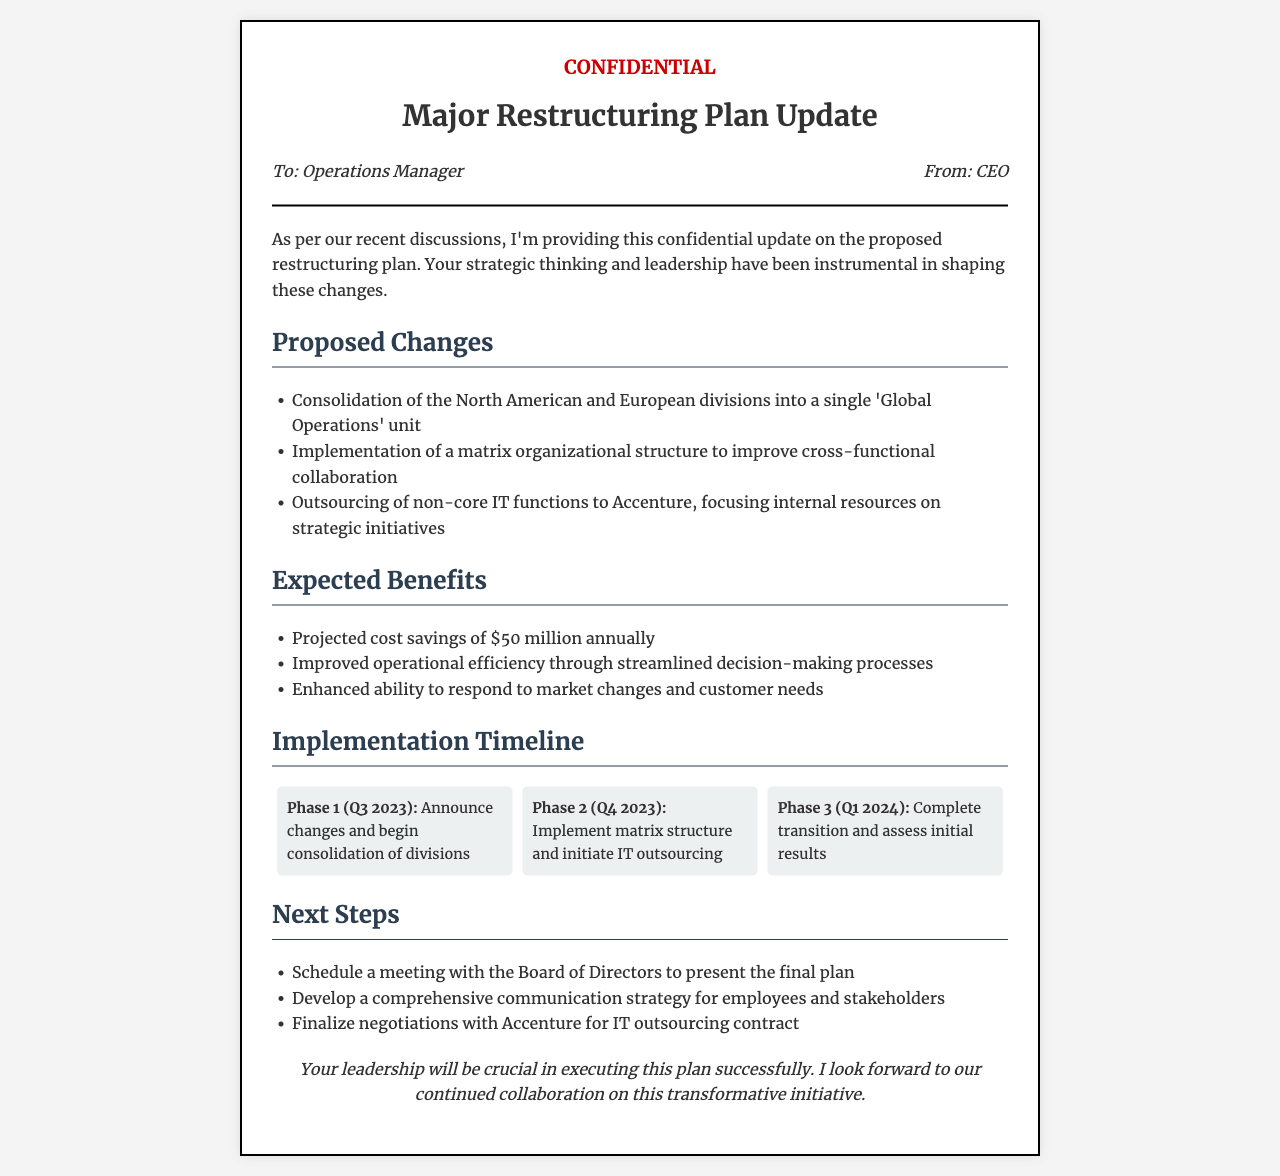what is the projected annual cost savings? The document states that the projected cost savings as a result of the restructuring is $50 million annually.
Answer: $50 million who is the sender of the document? The sender is identified as the CEO in the header section of the document.
Answer: CEO what is the first phase of the implementation timeline? The first phase, labeled Phase 1, involves announcing changes and beginning the consolidation of divisions.
Answer: Announce changes and begin consolidation of divisions which company is mentioned for IT outsourcing? The document mentions that non-core IT functions will be outsourced to Accenture.
Answer: Accenture what is expected to be improved through the matrix organizational structure? The document indicates that the matrix organizational structure aims to improve cross-functional collaboration.
Answer: Cross-functional collaboration how many phases are outlined in the implementation timeline? The document outlines three distinct phases in the implementation timeline for the restructuring plan.
Answer: Three what is a next step mentioned for the operations manager? One next step indicated is to schedule a meeting with the Board of Directors to present the final plan.
Answer: Schedule a meeting with the Board of Directors what is emphasized at the end of the document regarding the operations manager? The closing statement underscores that the operations manager's leadership will be crucial in executing the restructuring plan successfully.
Answer: Leadership will be crucial 